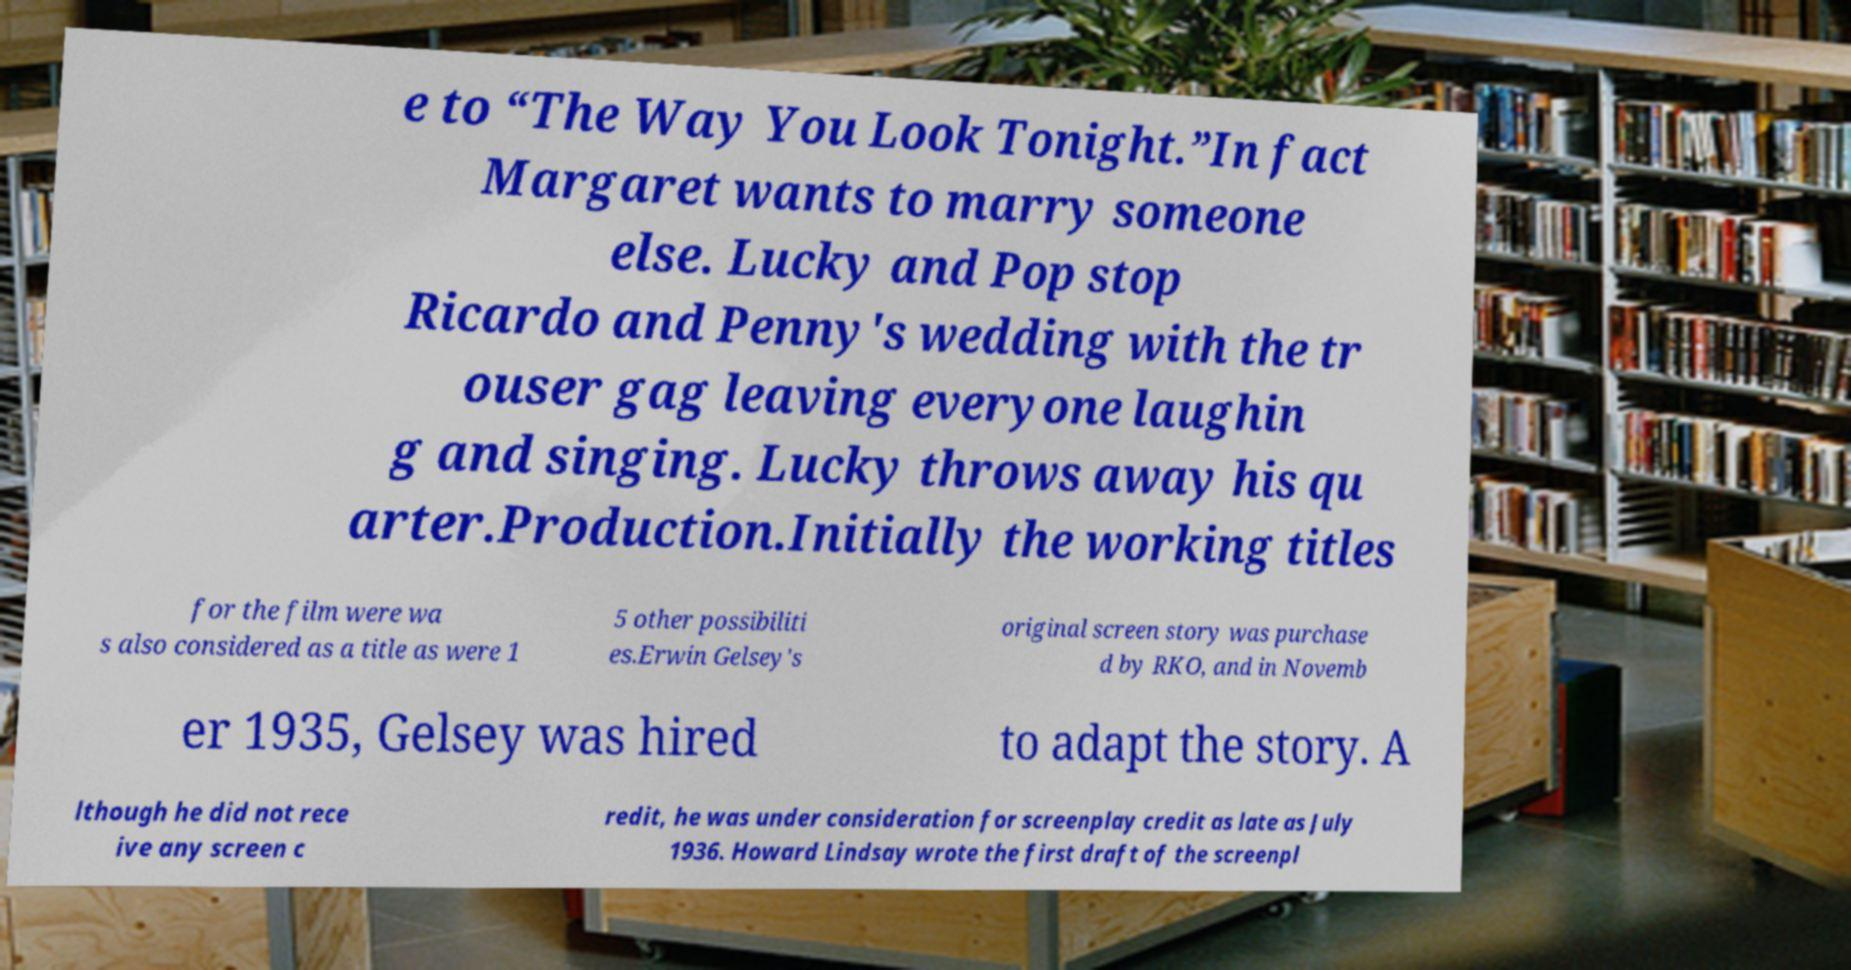For documentation purposes, I need the text within this image transcribed. Could you provide that? e to “The Way You Look Tonight.”In fact Margaret wants to marry someone else. Lucky and Pop stop Ricardo and Penny's wedding with the tr ouser gag leaving everyone laughin g and singing. Lucky throws away his qu arter.Production.Initially the working titles for the film were wa s also considered as a title as were 1 5 other possibiliti es.Erwin Gelsey's original screen story was purchase d by RKO, and in Novemb er 1935, Gelsey was hired to adapt the story. A lthough he did not rece ive any screen c redit, he was under consideration for screenplay credit as late as July 1936. Howard Lindsay wrote the first draft of the screenpl 